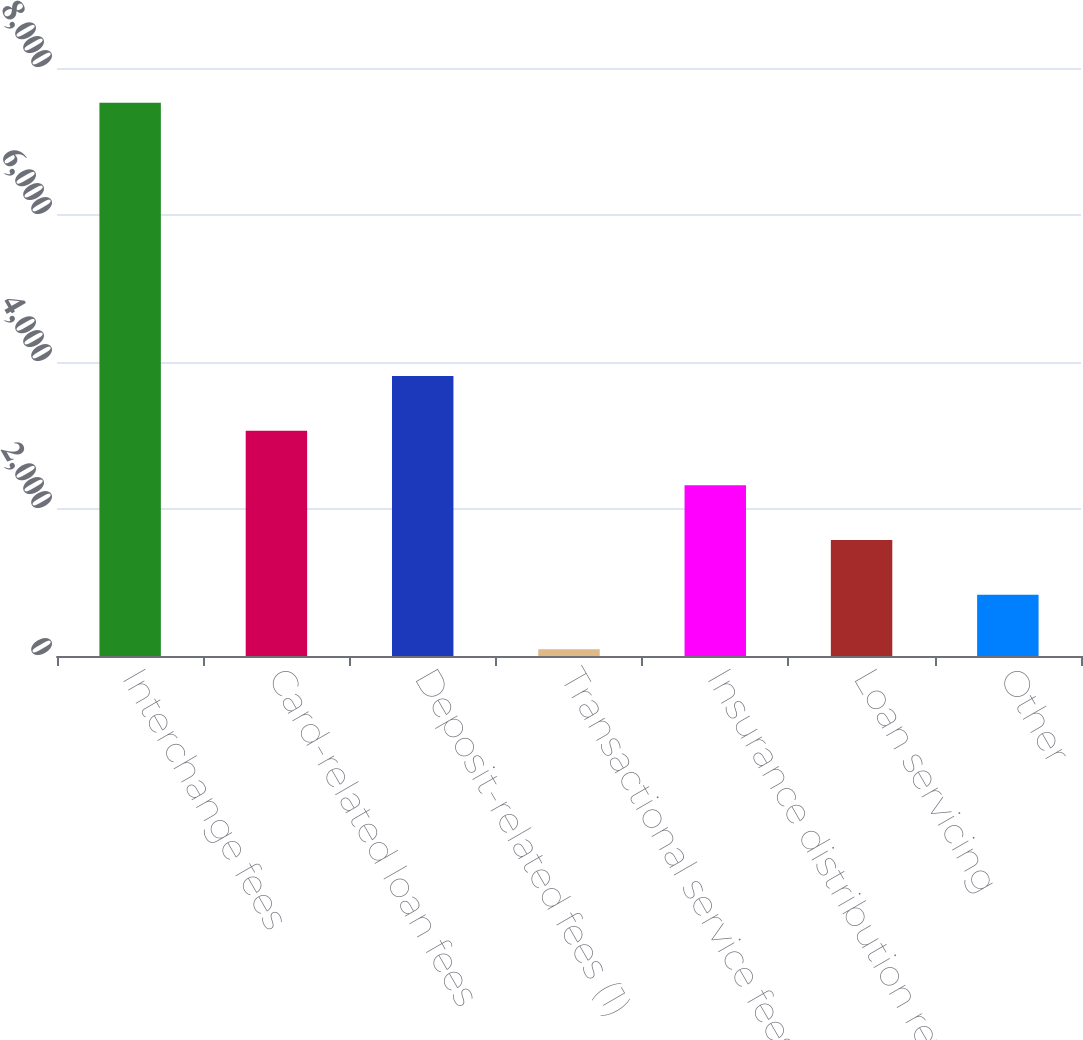<chart> <loc_0><loc_0><loc_500><loc_500><bar_chart><fcel>Interchange fees<fcel>Card-related loan fees<fcel>Deposit-related fees (1)<fcel>Transactional service fees<fcel>Insurance distribution revenue<fcel>Loan servicing<fcel>Other<nl><fcel>7526<fcel>3065<fcel>3808.5<fcel>91<fcel>2321.5<fcel>1578<fcel>834.5<nl></chart> 